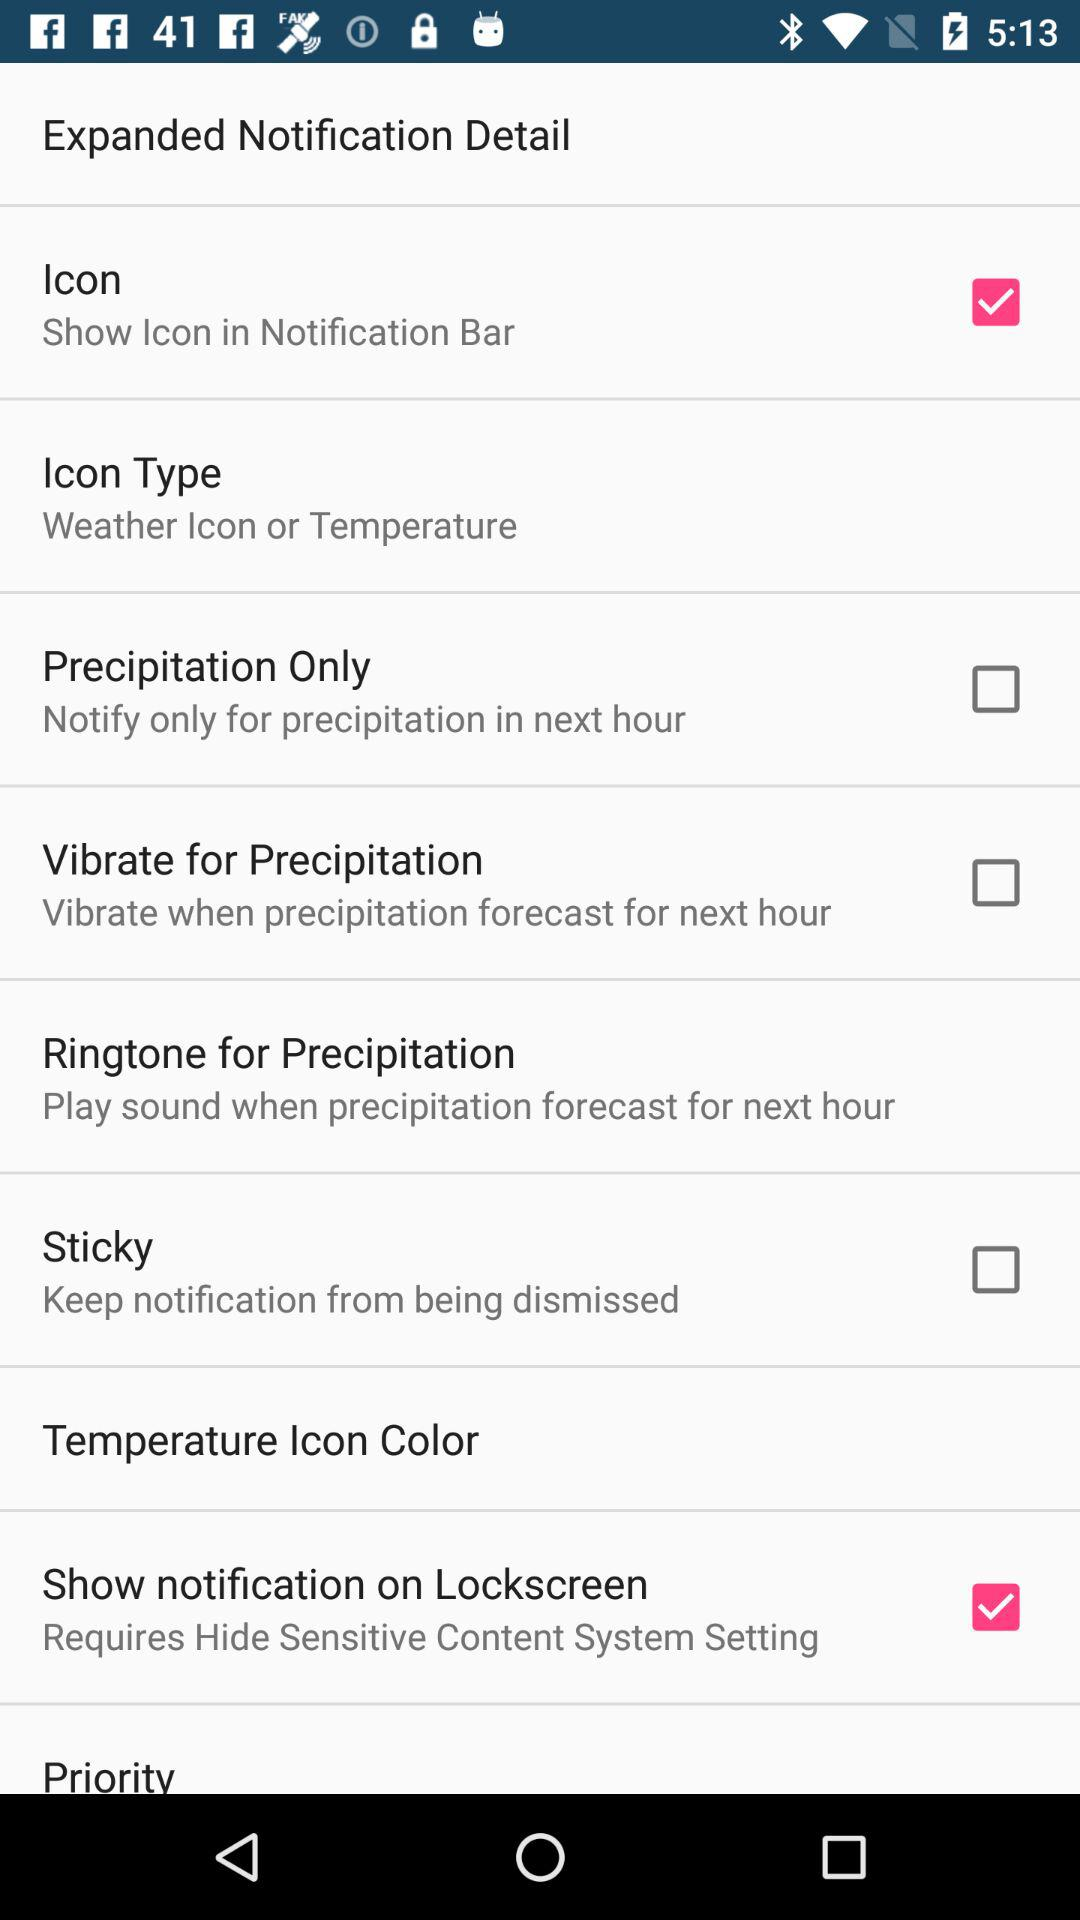What description is given in the ringtone for percipitation? The given description is "Play sound when precipitation forecast for next hour". 